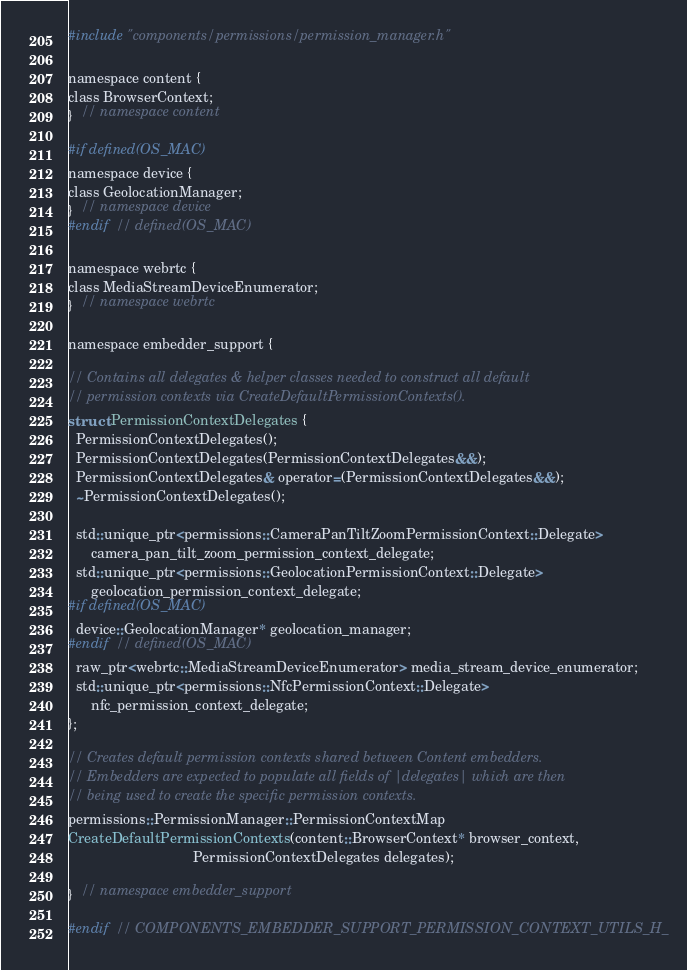Convert code to text. <code><loc_0><loc_0><loc_500><loc_500><_C_>#include "components/permissions/permission_manager.h"

namespace content {
class BrowserContext;
}  // namespace content

#if defined(OS_MAC)
namespace device {
class GeolocationManager;
}  // namespace device
#endif  // defined(OS_MAC)

namespace webrtc {
class MediaStreamDeviceEnumerator;
}  // namespace webrtc

namespace embedder_support {

// Contains all delegates & helper classes needed to construct all default
// permission contexts via CreateDefaultPermissionContexts().
struct PermissionContextDelegates {
  PermissionContextDelegates();
  PermissionContextDelegates(PermissionContextDelegates&&);
  PermissionContextDelegates& operator=(PermissionContextDelegates&&);
  ~PermissionContextDelegates();

  std::unique_ptr<permissions::CameraPanTiltZoomPermissionContext::Delegate>
      camera_pan_tilt_zoom_permission_context_delegate;
  std::unique_ptr<permissions::GeolocationPermissionContext::Delegate>
      geolocation_permission_context_delegate;
#if defined(OS_MAC)
  device::GeolocationManager* geolocation_manager;
#endif  // defined(OS_MAC)
  raw_ptr<webrtc::MediaStreamDeviceEnumerator> media_stream_device_enumerator;
  std::unique_ptr<permissions::NfcPermissionContext::Delegate>
      nfc_permission_context_delegate;
};

// Creates default permission contexts shared between Content embedders.
// Embedders are expected to populate all fields of |delegates| which are then
// being used to create the specific permission contexts.
permissions::PermissionManager::PermissionContextMap
CreateDefaultPermissionContexts(content::BrowserContext* browser_context,
                                PermissionContextDelegates delegates);

}  // namespace embedder_support

#endif  // COMPONENTS_EMBEDDER_SUPPORT_PERMISSION_CONTEXT_UTILS_H_
</code> 